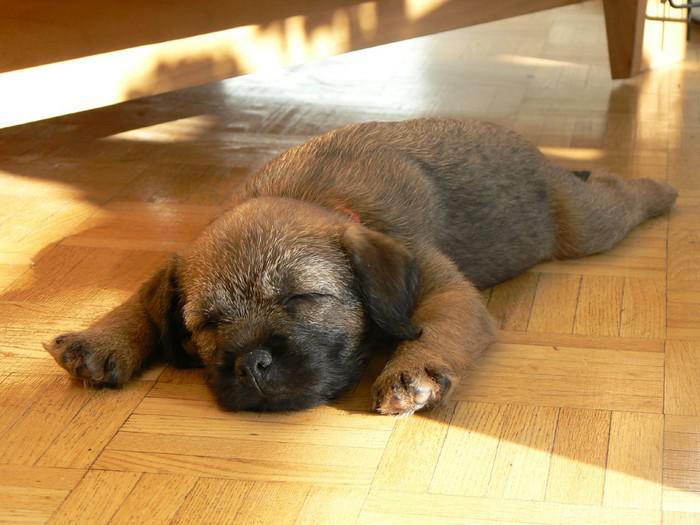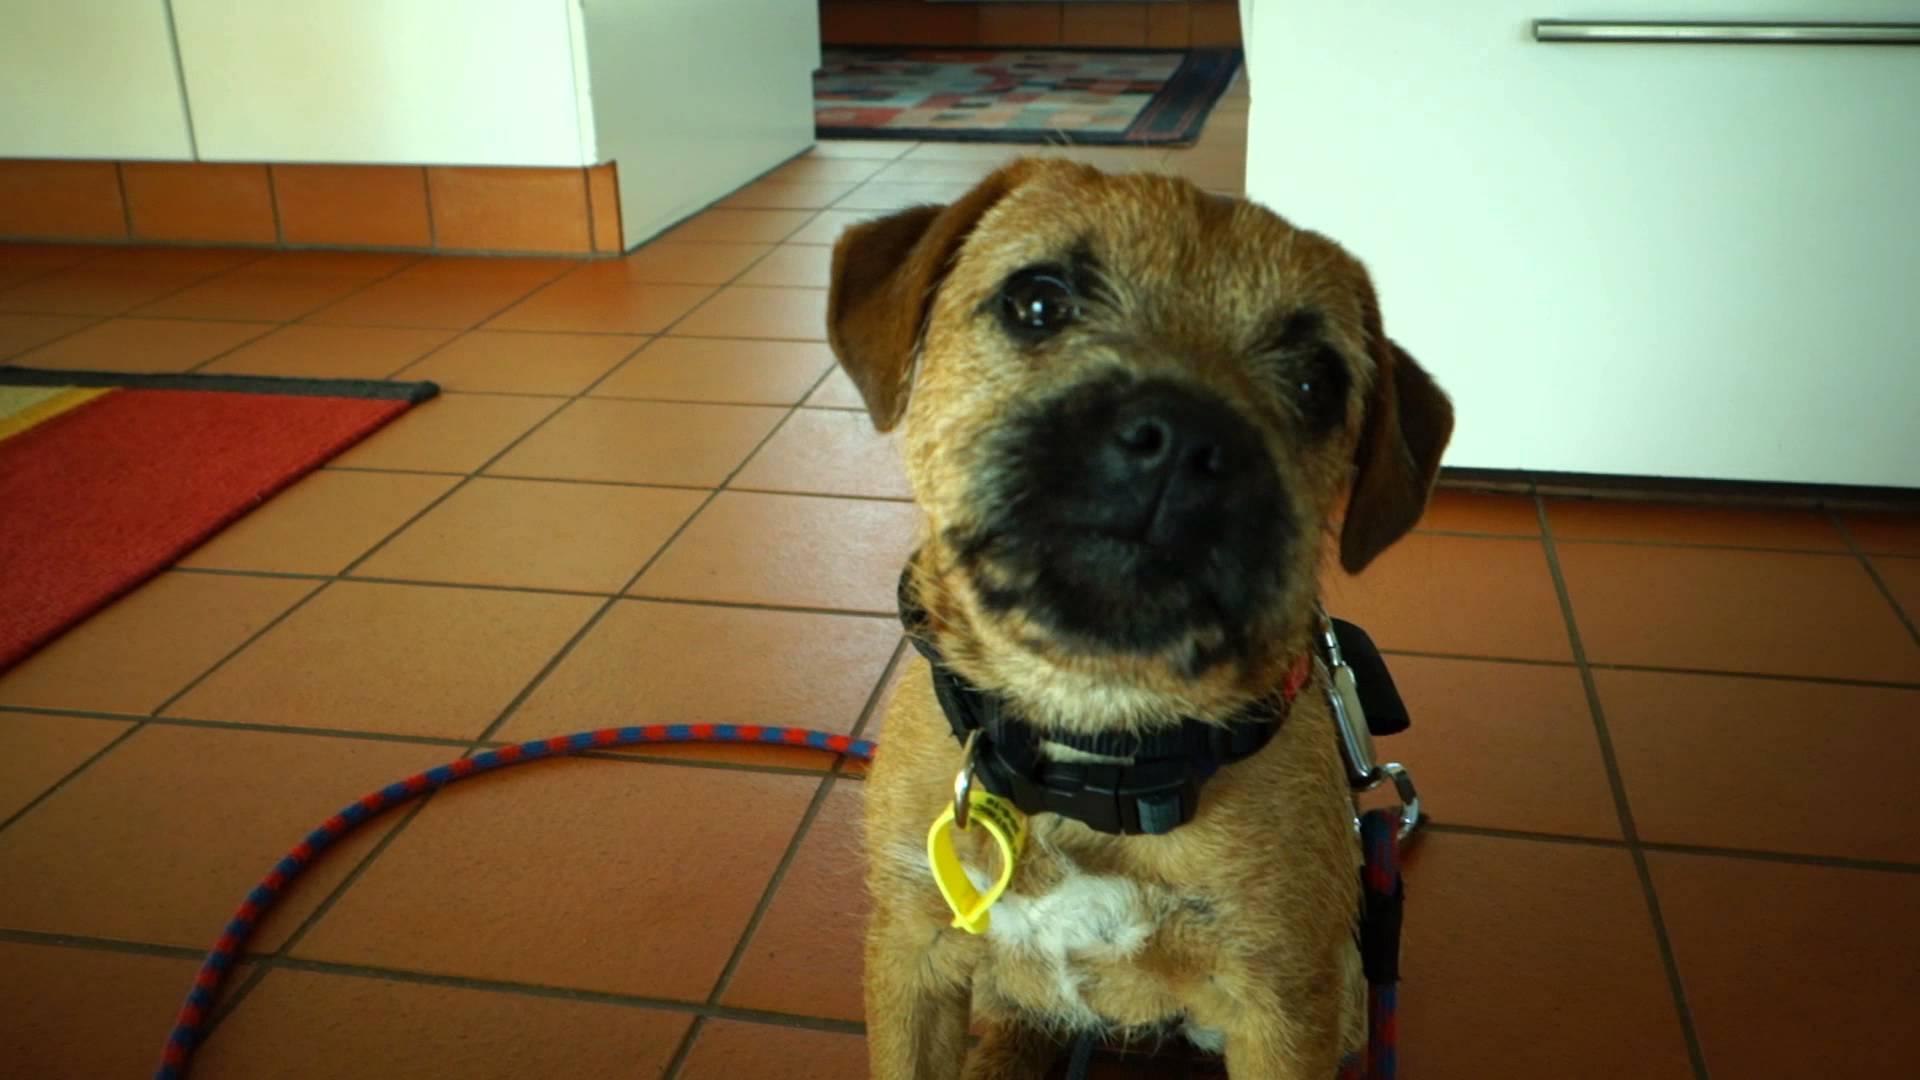The first image is the image on the left, the second image is the image on the right. Assess this claim about the two images: "There is a dog sitting upright inside in the right image.". Correct or not? Answer yes or no. Yes. The first image is the image on the left, the second image is the image on the right. Given the left and right images, does the statement "Atleast one image contains a sleeping or growling dog." hold true? Answer yes or no. Yes. 